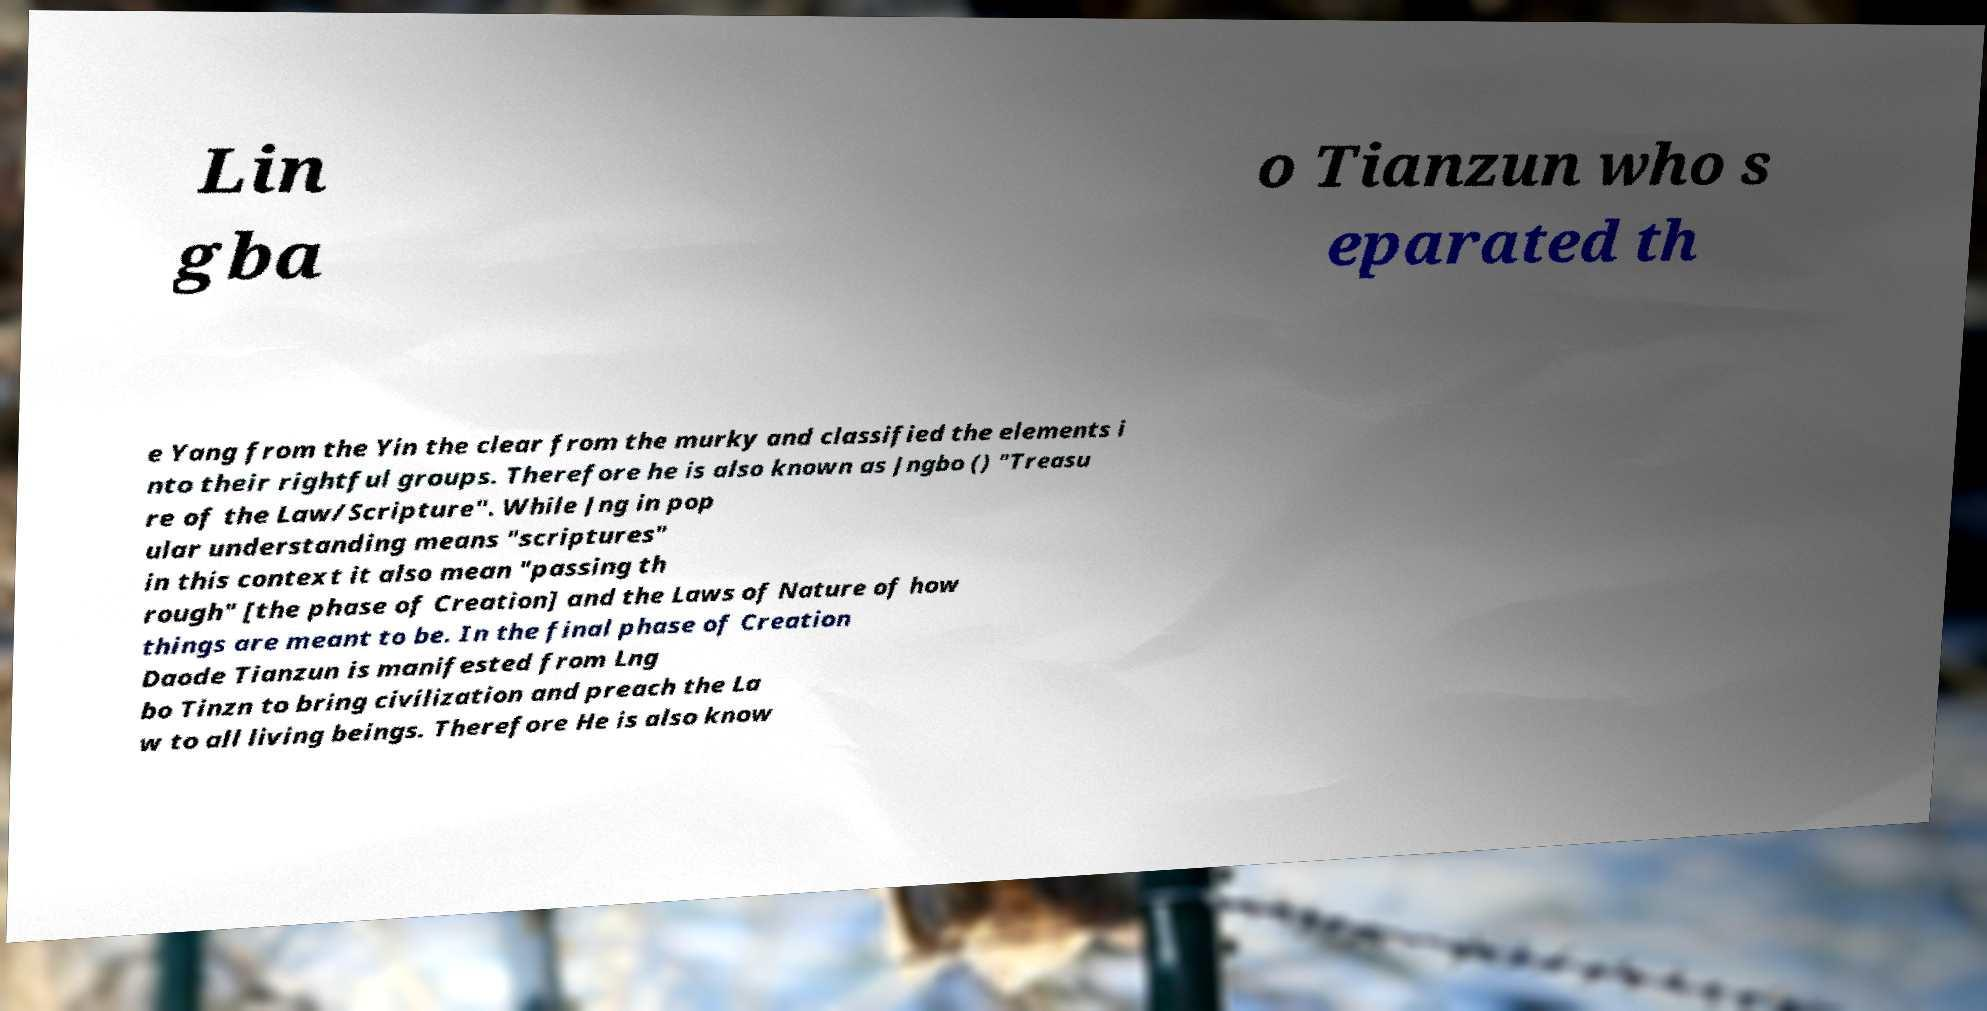Please read and relay the text visible in this image. What does it say? Lin gba o Tianzun who s eparated th e Yang from the Yin the clear from the murky and classified the elements i nto their rightful groups. Therefore he is also known as Jngbo () "Treasu re of the Law/Scripture". While Jng in pop ular understanding means "scriptures" in this context it also mean "passing th rough" [the phase of Creation] and the Laws of Nature of how things are meant to be. In the final phase of Creation Daode Tianzun is manifested from Lng bo Tinzn to bring civilization and preach the La w to all living beings. Therefore He is also know 